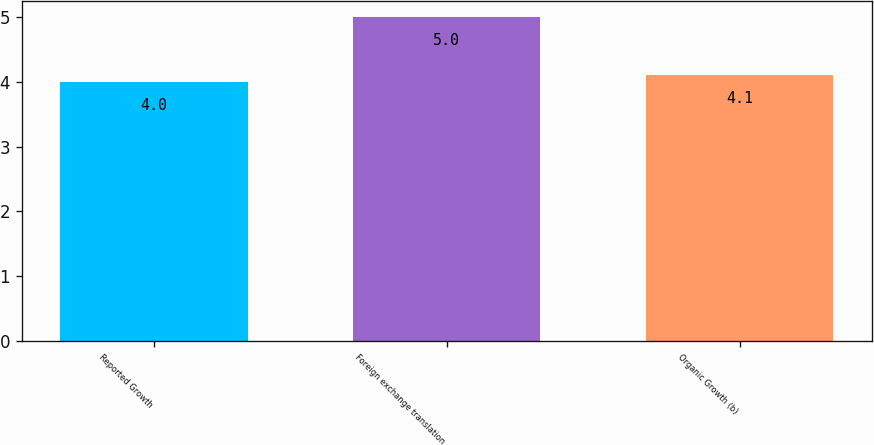Convert chart. <chart><loc_0><loc_0><loc_500><loc_500><bar_chart><fcel>Reported Growth<fcel>Foreign exchange translation<fcel>Organic Growth (b)<nl><fcel>4<fcel>5<fcel>4.1<nl></chart> 